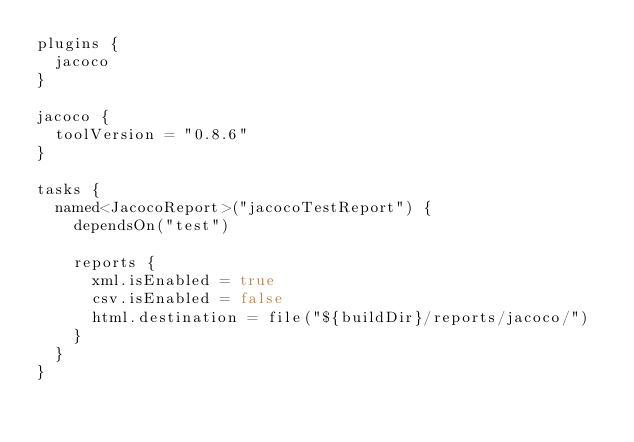Convert code to text. <code><loc_0><loc_0><loc_500><loc_500><_Kotlin_>plugins {
  jacoco
}

jacoco {
  toolVersion = "0.8.6"
}

tasks {
  named<JacocoReport>("jacocoTestReport") {
    dependsOn("test")

    reports {
      xml.isEnabled = true
      csv.isEnabled = false
      html.destination = file("${buildDir}/reports/jacoco/")
    }
  }
}
</code> 